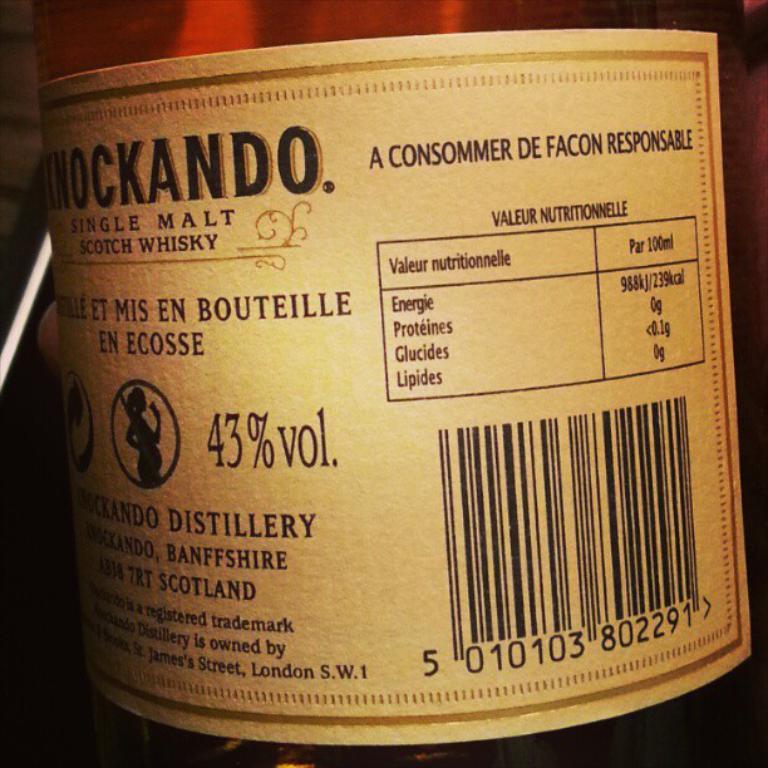What is the alcohol volume in this whiskey?
Provide a succinct answer. 43%. What kind of liquor is in this bottle?
Your response must be concise. Scotch whisky. 